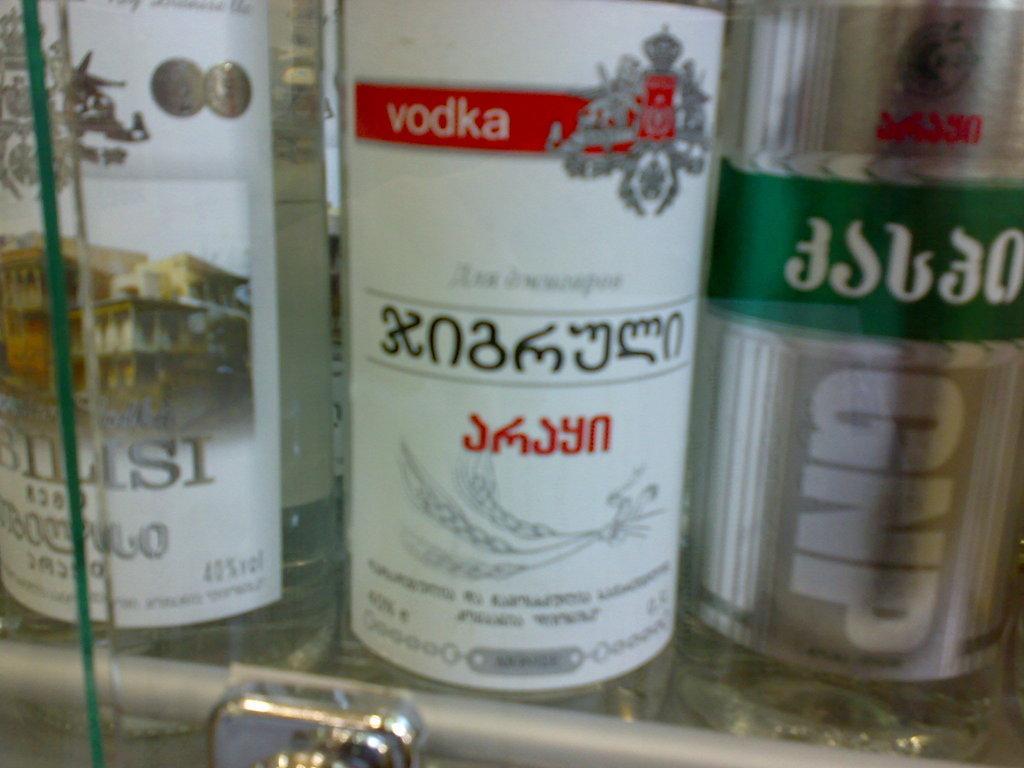In one or two sentences, can you explain what this image depicts? In the image we can see there are wine bottles which are kept in the shelf and on the wine bottle its written "Vodka". 